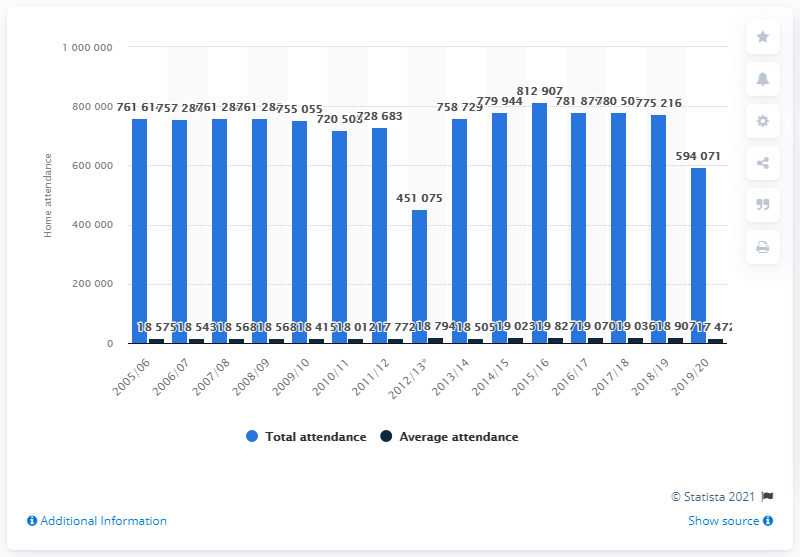Draw attention to some important aspects in this diagram. The last regular season home attendance of the Minnesota Wild franchise was in the 2005/2006 season. 